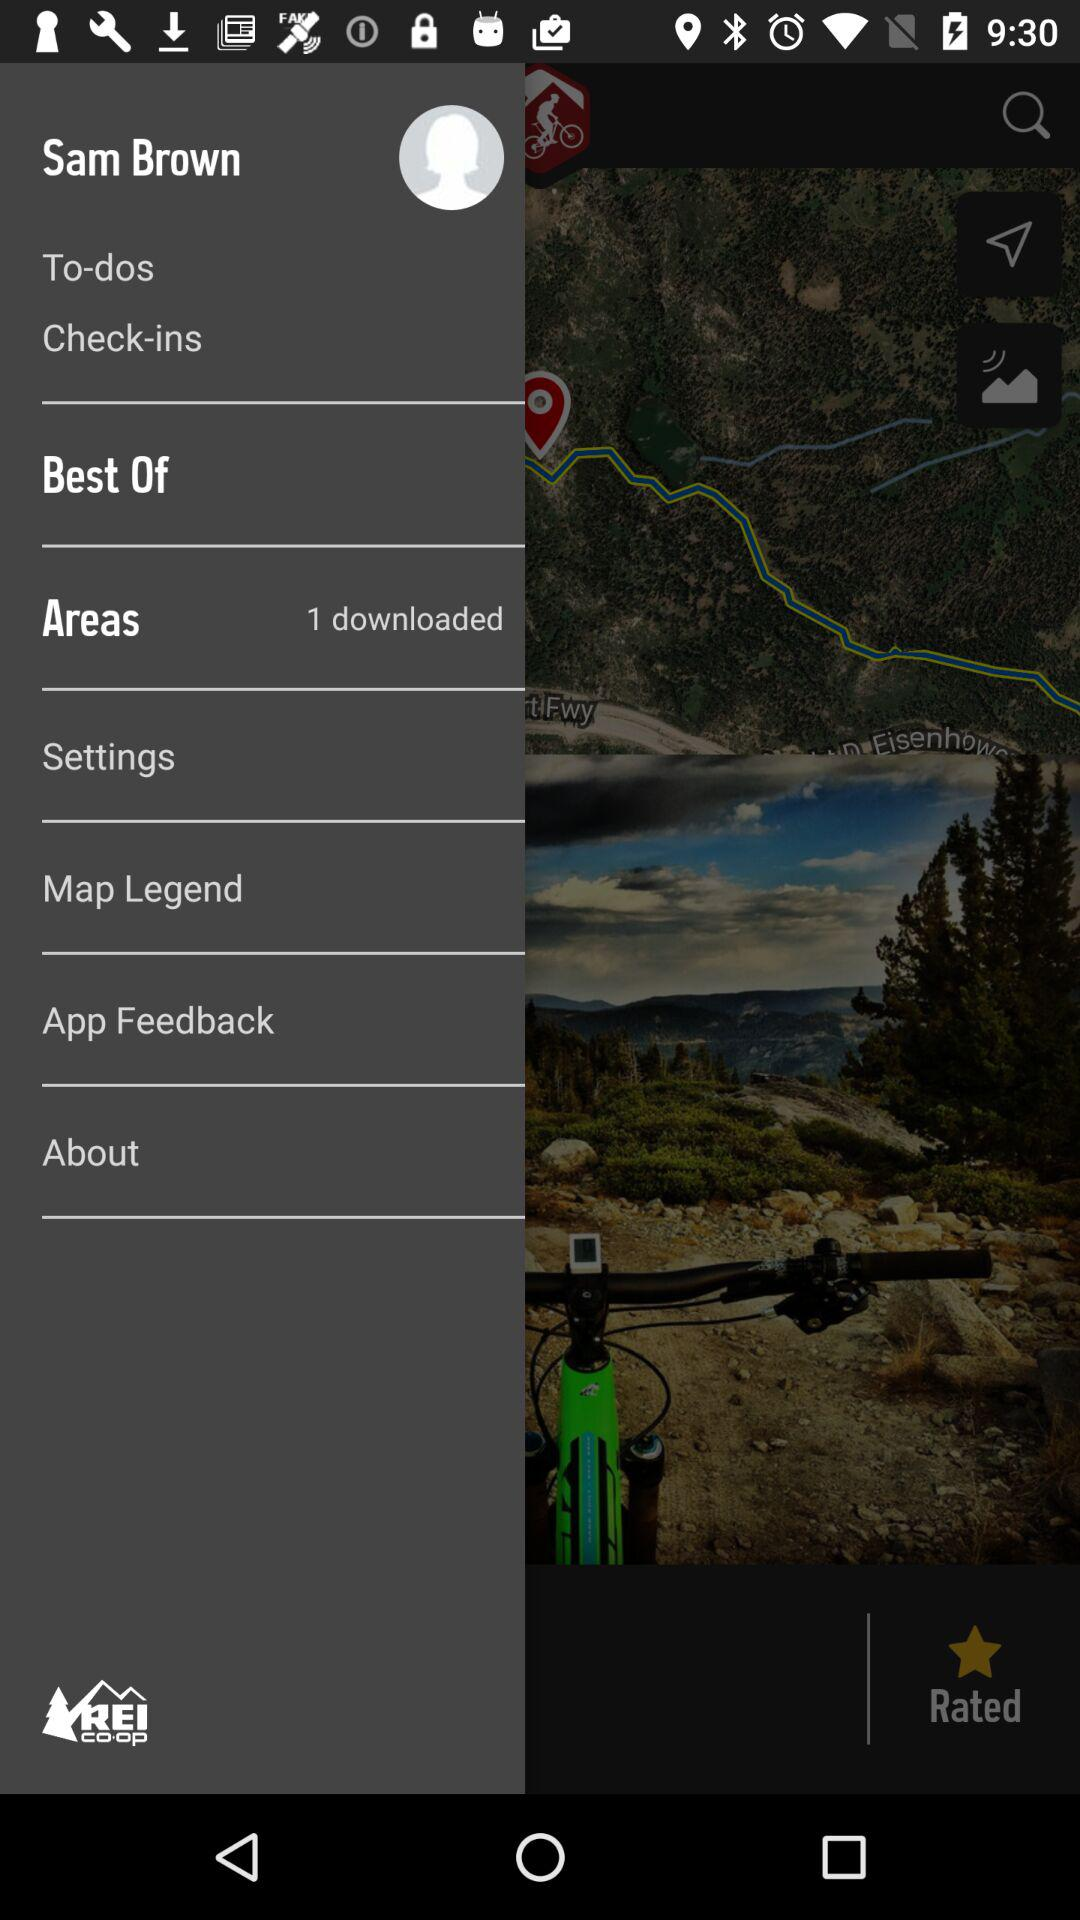What is the user name? The user name is Sam Brown. 